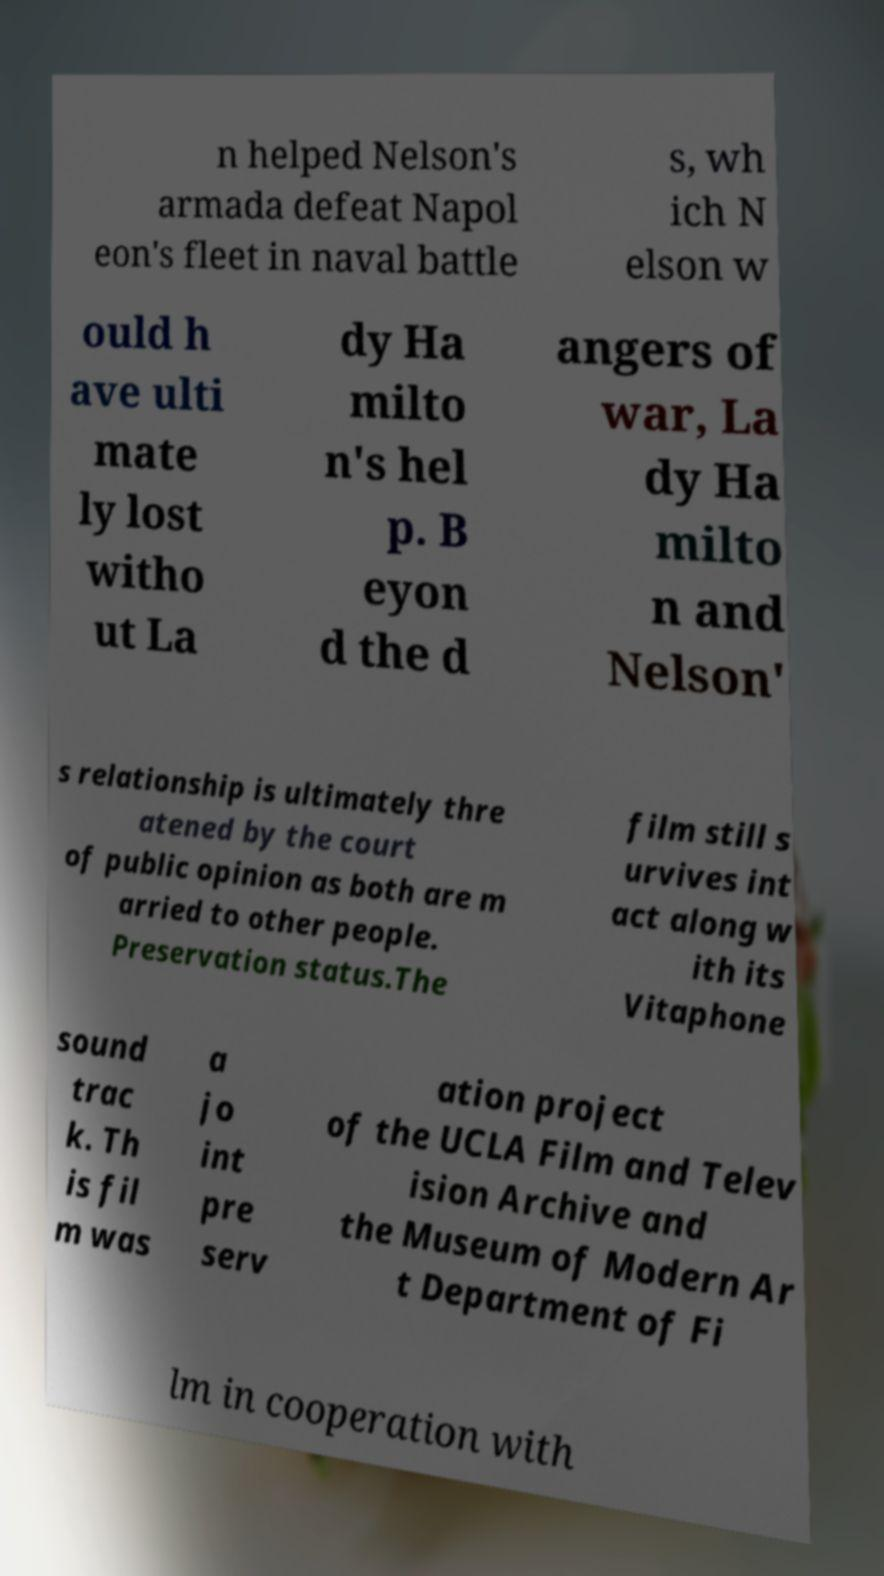I need the written content from this picture converted into text. Can you do that? n helped Nelson's armada defeat Napol eon's fleet in naval battle s, wh ich N elson w ould h ave ulti mate ly lost witho ut La dy Ha milto n's hel p. B eyon d the d angers of war, La dy Ha milto n and Nelson' s relationship is ultimately thre atened by the court of public opinion as both are m arried to other people. Preservation status.The film still s urvives int act along w ith its Vitaphone sound trac k. Th is fil m was a jo int pre serv ation project of the UCLA Film and Telev ision Archive and the Museum of Modern Ar t Department of Fi lm in cooperation with 